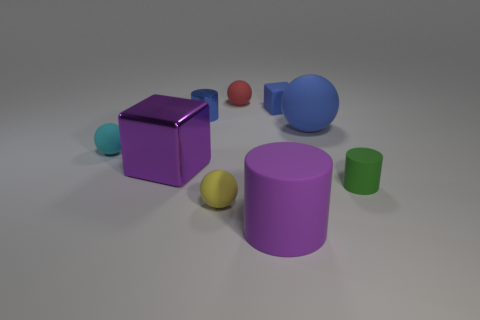Are there the same number of tiny matte things on the left side of the purple metallic object and rubber things that are behind the large blue rubber object? After reviewing the image, it appears that there is one tiny matte object on the left side of the purple metallic cube; this is a small teal sphere. Behind the large blue rubber cylinder, there is one small red rubber ball. Therefore, the number of tiny matte and rubber things in the specified locations is indeed equal: there is one of each. 